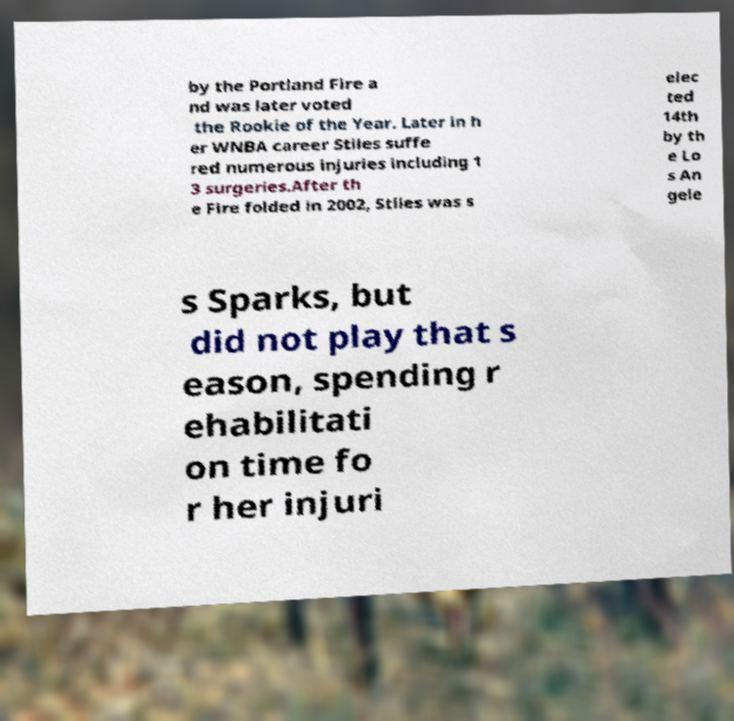I need the written content from this picture converted into text. Can you do that? by the Portland Fire a nd was later voted the Rookie of the Year. Later in h er WNBA career Stiles suffe red numerous injuries including 1 3 surgeries.After th e Fire folded in 2002, Stiles was s elec ted 14th by th e Lo s An gele s Sparks, but did not play that s eason, spending r ehabilitati on time fo r her injuri 